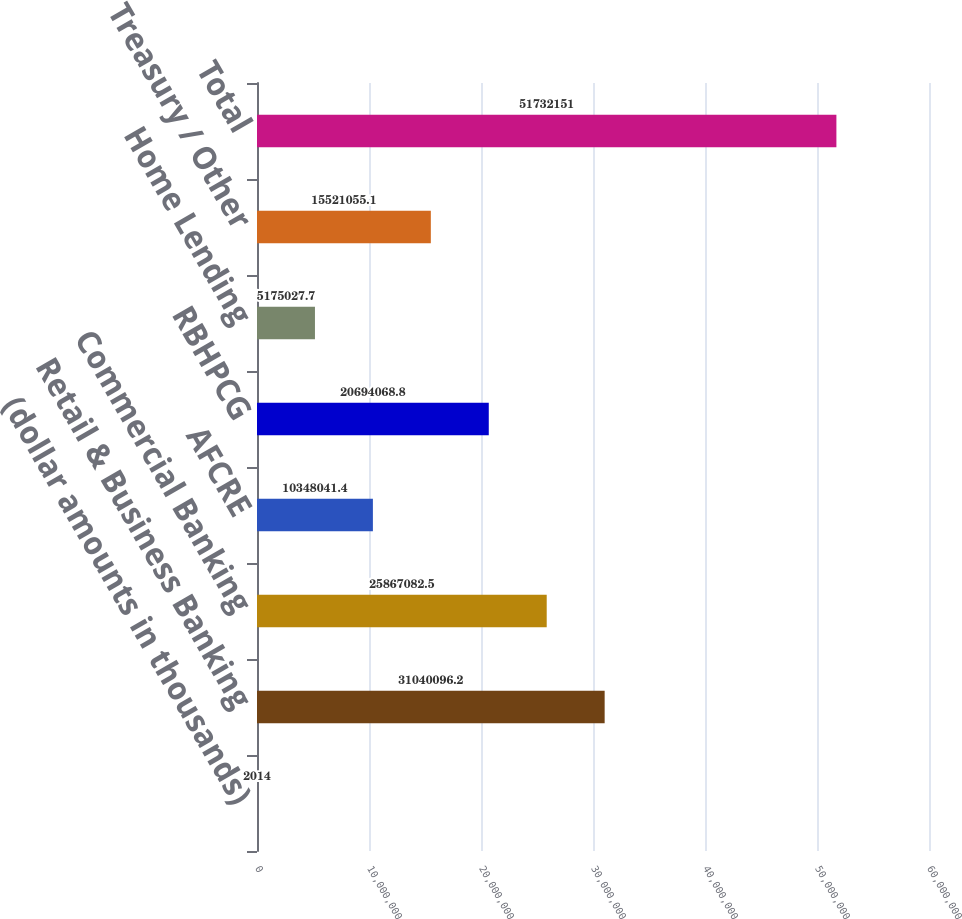<chart> <loc_0><loc_0><loc_500><loc_500><bar_chart><fcel>(dollar amounts in thousands)<fcel>Retail & Business Banking<fcel>Commercial Banking<fcel>AFCRE<fcel>RBHPCG<fcel>Home Lending<fcel>Treasury / Other<fcel>Total<nl><fcel>2014<fcel>3.10401e+07<fcel>2.58671e+07<fcel>1.0348e+07<fcel>2.06941e+07<fcel>5.17503e+06<fcel>1.55211e+07<fcel>5.17322e+07<nl></chart> 